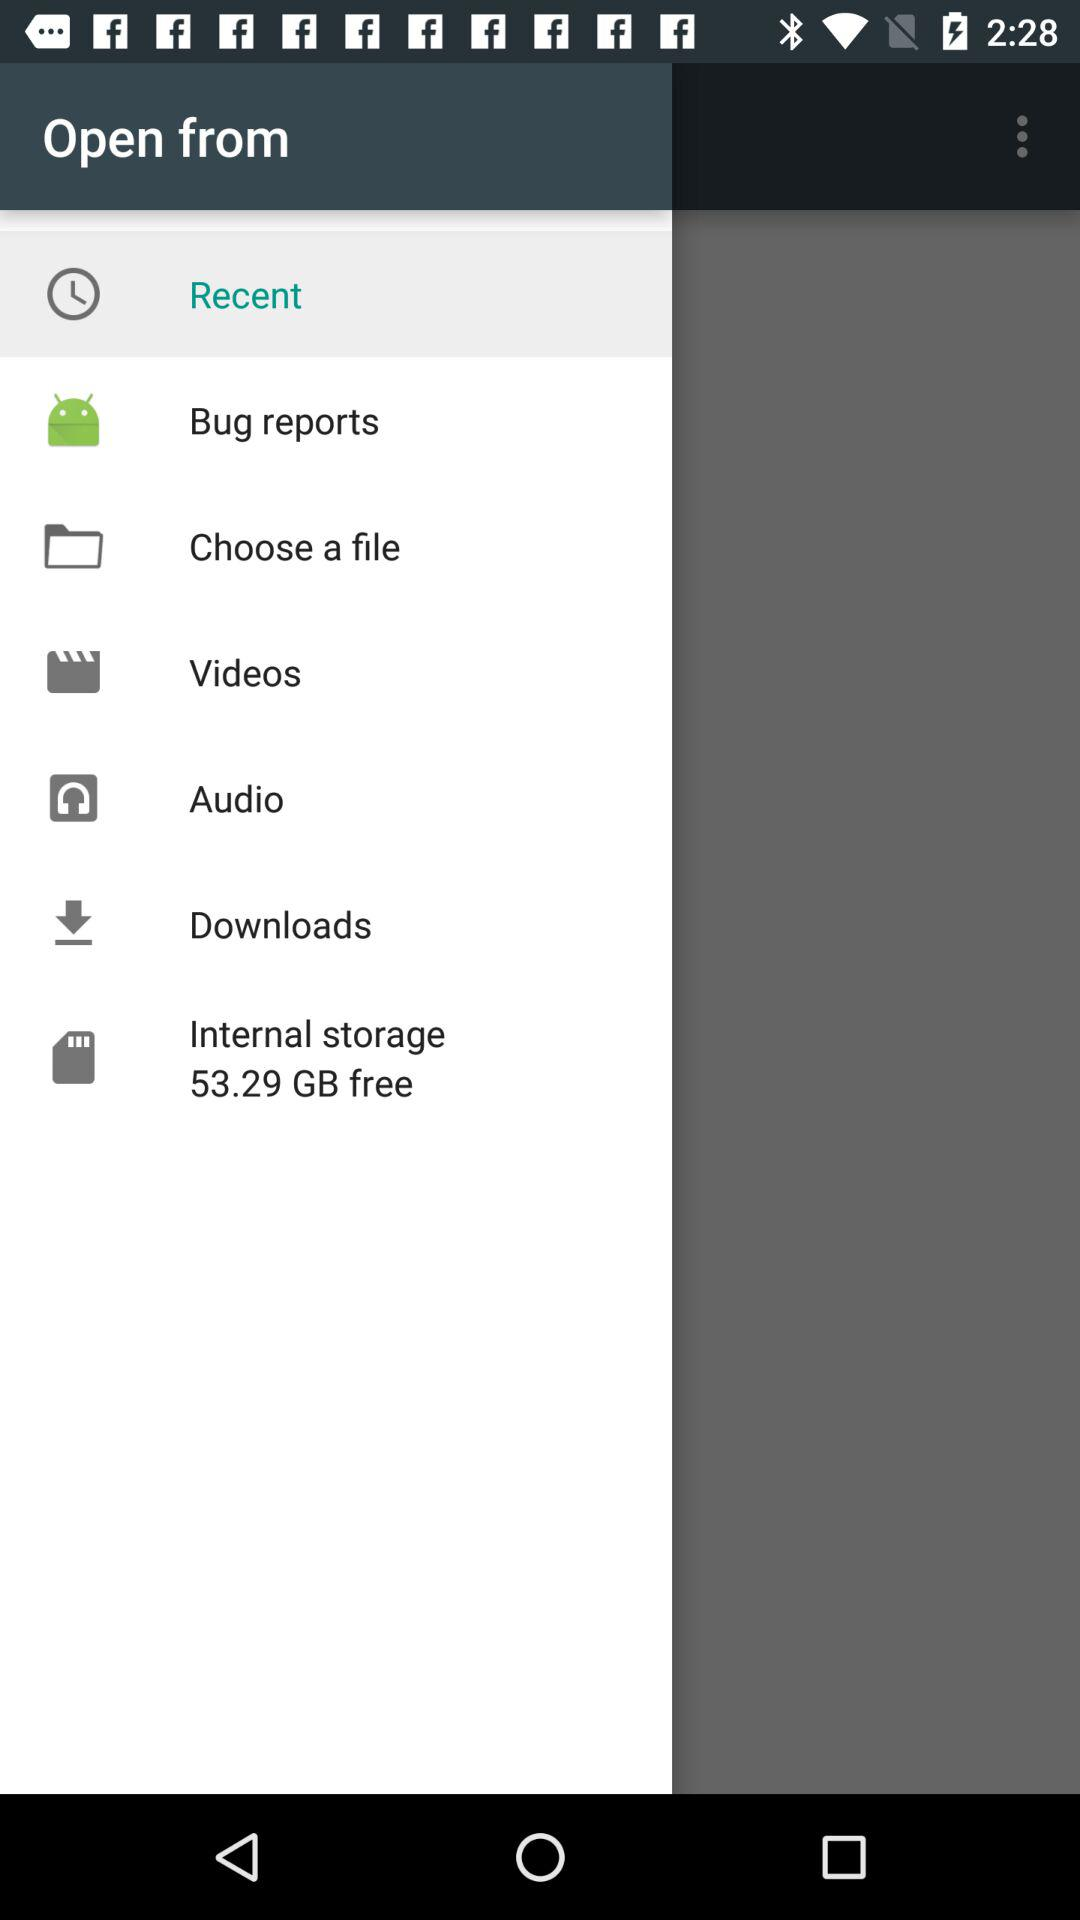How much is the free internal storage? The free internal storage is 53.29 GB. 